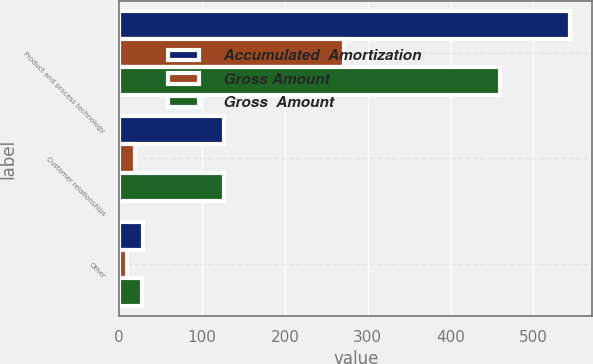Convert chart. <chart><loc_0><loc_0><loc_500><loc_500><stacked_bar_chart><ecel><fcel>Product and process technology<fcel>Customer relationships<fcel>Other<nl><fcel>Accumulated  Amortization<fcel>544<fcel>127<fcel>29<nl><fcel>Gross Amount<fcel>271<fcel>19<fcel>9<nl><fcel>Gross  Amount<fcel>460<fcel>127<fcel>27<nl></chart> 